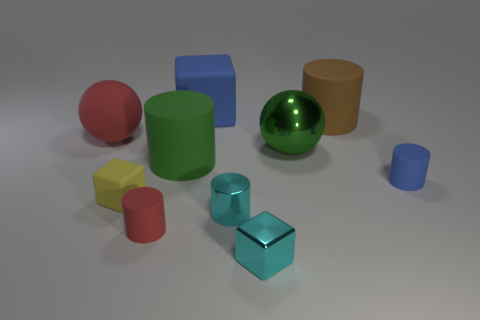Is the color of the matte thing that is behind the large brown matte cylinder the same as the tiny metallic cube?
Your response must be concise. No. What is the shape of the tiny rubber object that is right of the big cylinder that is to the left of the small cyan thing behind the small red cylinder?
Give a very brief answer. Cylinder. Does the blue cylinder have the same size as the red object right of the tiny yellow thing?
Offer a very short reply. Yes. Is there a brown thing of the same size as the green shiny object?
Make the answer very short. Yes. What number of other things are there of the same material as the tiny cyan cylinder
Give a very brief answer. 2. What color is the object that is both left of the small red rubber cylinder and behind the yellow rubber block?
Offer a terse response. Red. Does the blue object that is in front of the big cube have the same material as the tiny block that is in front of the small red cylinder?
Your response must be concise. No. There is a blue thing that is behind the brown matte cylinder; does it have the same size as the red cylinder?
Keep it short and to the point. No. Does the metal cylinder have the same color as the block that is right of the blue cube?
Give a very brief answer. Yes. What is the shape of the rubber object that is the same color as the rubber ball?
Your answer should be very brief. Cylinder. 